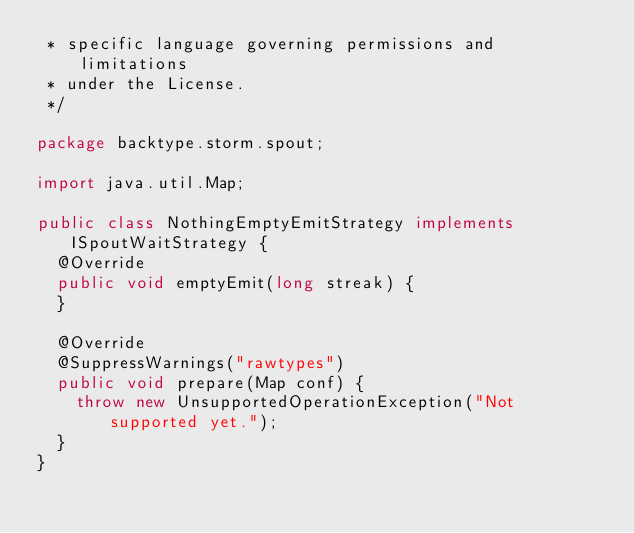<code> <loc_0><loc_0><loc_500><loc_500><_Java_> * specific language governing permissions and limitations
 * under the License.
 */

package backtype.storm.spout;

import java.util.Map;

public class NothingEmptyEmitStrategy implements ISpoutWaitStrategy {
  @Override
  public void emptyEmit(long streak) {
  }

  @Override
  @SuppressWarnings("rawtypes")
  public void prepare(Map conf) {
    throw new UnsupportedOperationException("Not supported yet.");
  }
}
</code> 